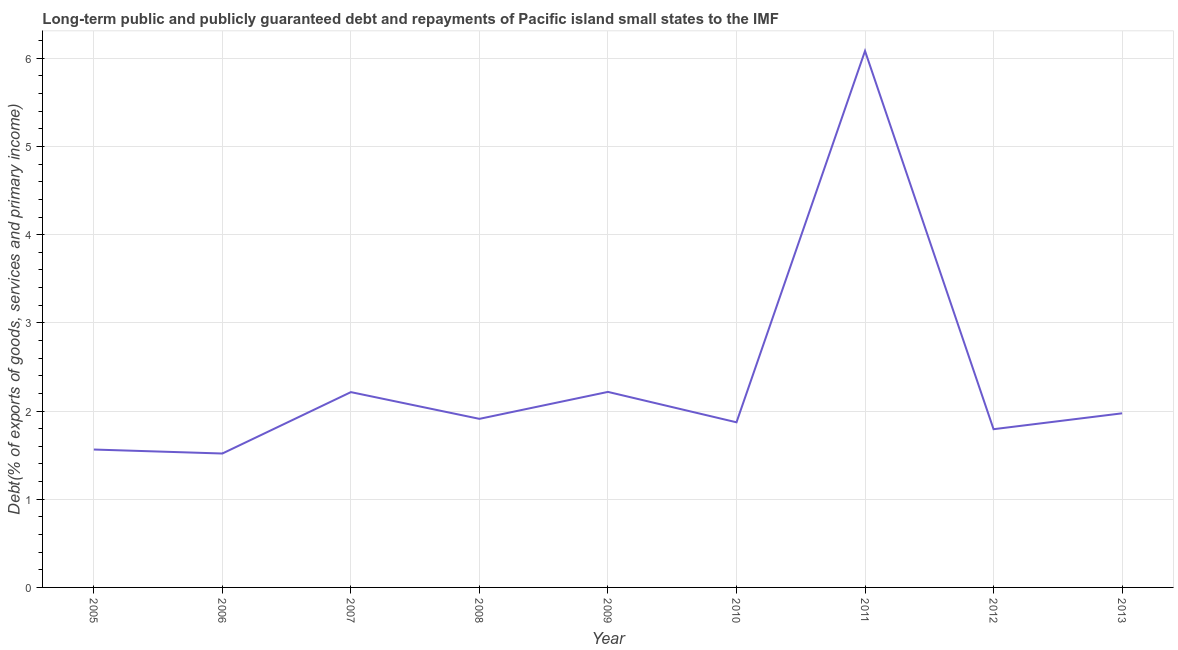What is the debt service in 2010?
Keep it short and to the point. 1.87. Across all years, what is the maximum debt service?
Provide a succinct answer. 6.08. Across all years, what is the minimum debt service?
Provide a succinct answer. 1.52. In which year was the debt service maximum?
Ensure brevity in your answer.  2011. In which year was the debt service minimum?
Provide a succinct answer. 2006. What is the sum of the debt service?
Keep it short and to the point. 21.15. What is the difference between the debt service in 2006 and 2012?
Ensure brevity in your answer.  -0.28. What is the average debt service per year?
Offer a terse response. 2.35. What is the median debt service?
Your answer should be very brief. 1.91. In how many years, is the debt service greater than 4.6 %?
Offer a very short reply. 1. What is the ratio of the debt service in 2007 to that in 2012?
Your answer should be compact. 1.23. What is the difference between the highest and the second highest debt service?
Offer a terse response. 3.87. Is the sum of the debt service in 2010 and 2013 greater than the maximum debt service across all years?
Offer a very short reply. No. What is the difference between the highest and the lowest debt service?
Provide a short and direct response. 4.56. In how many years, is the debt service greater than the average debt service taken over all years?
Ensure brevity in your answer.  1. What is the difference between two consecutive major ticks on the Y-axis?
Give a very brief answer. 1. Are the values on the major ticks of Y-axis written in scientific E-notation?
Provide a short and direct response. No. What is the title of the graph?
Provide a short and direct response. Long-term public and publicly guaranteed debt and repayments of Pacific island small states to the IMF. What is the label or title of the X-axis?
Give a very brief answer. Year. What is the label or title of the Y-axis?
Your answer should be very brief. Debt(% of exports of goods, services and primary income). What is the Debt(% of exports of goods, services and primary income) of 2005?
Your answer should be very brief. 1.56. What is the Debt(% of exports of goods, services and primary income) of 2006?
Your answer should be very brief. 1.52. What is the Debt(% of exports of goods, services and primary income) of 2007?
Ensure brevity in your answer.  2.21. What is the Debt(% of exports of goods, services and primary income) of 2008?
Ensure brevity in your answer.  1.91. What is the Debt(% of exports of goods, services and primary income) of 2009?
Give a very brief answer. 2.22. What is the Debt(% of exports of goods, services and primary income) in 2010?
Provide a short and direct response. 1.87. What is the Debt(% of exports of goods, services and primary income) of 2011?
Give a very brief answer. 6.08. What is the Debt(% of exports of goods, services and primary income) in 2012?
Ensure brevity in your answer.  1.79. What is the Debt(% of exports of goods, services and primary income) in 2013?
Offer a terse response. 1.97. What is the difference between the Debt(% of exports of goods, services and primary income) in 2005 and 2006?
Offer a very short reply. 0.05. What is the difference between the Debt(% of exports of goods, services and primary income) in 2005 and 2007?
Offer a very short reply. -0.65. What is the difference between the Debt(% of exports of goods, services and primary income) in 2005 and 2008?
Provide a succinct answer. -0.35. What is the difference between the Debt(% of exports of goods, services and primary income) in 2005 and 2009?
Your answer should be very brief. -0.65. What is the difference between the Debt(% of exports of goods, services and primary income) in 2005 and 2010?
Make the answer very short. -0.31. What is the difference between the Debt(% of exports of goods, services and primary income) in 2005 and 2011?
Your response must be concise. -4.52. What is the difference between the Debt(% of exports of goods, services and primary income) in 2005 and 2012?
Keep it short and to the point. -0.23. What is the difference between the Debt(% of exports of goods, services and primary income) in 2005 and 2013?
Give a very brief answer. -0.41. What is the difference between the Debt(% of exports of goods, services and primary income) in 2006 and 2007?
Make the answer very short. -0.7. What is the difference between the Debt(% of exports of goods, services and primary income) in 2006 and 2008?
Offer a very short reply. -0.39. What is the difference between the Debt(% of exports of goods, services and primary income) in 2006 and 2009?
Ensure brevity in your answer.  -0.7. What is the difference between the Debt(% of exports of goods, services and primary income) in 2006 and 2010?
Provide a short and direct response. -0.35. What is the difference between the Debt(% of exports of goods, services and primary income) in 2006 and 2011?
Keep it short and to the point. -4.57. What is the difference between the Debt(% of exports of goods, services and primary income) in 2006 and 2012?
Provide a short and direct response. -0.28. What is the difference between the Debt(% of exports of goods, services and primary income) in 2006 and 2013?
Ensure brevity in your answer.  -0.46. What is the difference between the Debt(% of exports of goods, services and primary income) in 2007 and 2008?
Your answer should be very brief. 0.3. What is the difference between the Debt(% of exports of goods, services and primary income) in 2007 and 2009?
Offer a very short reply. -0. What is the difference between the Debt(% of exports of goods, services and primary income) in 2007 and 2010?
Ensure brevity in your answer.  0.34. What is the difference between the Debt(% of exports of goods, services and primary income) in 2007 and 2011?
Your response must be concise. -3.87. What is the difference between the Debt(% of exports of goods, services and primary income) in 2007 and 2012?
Your answer should be compact. 0.42. What is the difference between the Debt(% of exports of goods, services and primary income) in 2007 and 2013?
Provide a short and direct response. 0.24. What is the difference between the Debt(% of exports of goods, services and primary income) in 2008 and 2009?
Give a very brief answer. -0.31. What is the difference between the Debt(% of exports of goods, services and primary income) in 2008 and 2010?
Provide a short and direct response. 0.04. What is the difference between the Debt(% of exports of goods, services and primary income) in 2008 and 2011?
Ensure brevity in your answer.  -4.17. What is the difference between the Debt(% of exports of goods, services and primary income) in 2008 and 2012?
Give a very brief answer. 0.12. What is the difference between the Debt(% of exports of goods, services and primary income) in 2008 and 2013?
Provide a short and direct response. -0.06. What is the difference between the Debt(% of exports of goods, services and primary income) in 2009 and 2010?
Make the answer very short. 0.34. What is the difference between the Debt(% of exports of goods, services and primary income) in 2009 and 2011?
Your answer should be compact. -3.87. What is the difference between the Debt(% of exports of goods, services and primary income) in 2009 and 2012?
Your response must be concise. 0.42. What is the difference between the Debt(% of exports of goods, services and primary income) in 2009 and 2013?
Offer a very short reply. 0.24. What is the difference between the Debt(% of exports of goods, services and primary income) in 2010 and 2011?
Ensure brevity in your answer.  -4.21. What is the difference between the Debt(% of exports of goods, services and primary income) in 2010 and 2012?
Keep it short and to the point. 0.08. What is the difference between the Debt(% of exports of goods, services and primary income) in 2010 and 2013?
Your response must be concise. -0.1. What is the difference between the Debt(% of exports of goods, services and primary income) in 2011 and 2012?
Ensure brevity in your answer.  4.29. What is the difference between the Debt(% of exports of goods, services and primary income) in 2011 and 2013?
Your answer should be very brief. 4.11. What is the difference between the Debt(% of exports of goods, services and primary income) in 2012 and 2013?
Keep it short and to the point. -0.18. What is the ratio of the Debt(% of exports of goods, services and primary income) in 2005 to that in 2007?
Your answer should be compact. 0.71. What is the ratio of the Debt(% of exports of goods, services and primary income) in 2005 to that in 2008?
Ensure brevity in your answer.  0.82. What is the ratio of the Debt(% of exports of goods, services and primary income) in 2005 to that in 2009?
Provide a short and direct response. 0.7. What is the ratio of the Debt(% of exports of goods, services and primary income) in 2005 to that in 2010?
Offer a terse response. 0.83. What is the ratio of the Debt(% of exports of goods, services and primary income) in 2005 to that in 2011?
Provide a short and direct response. 0.26. What is the ratio of the Debt(% of exports of goods, services and primary income) in 2005 to that in 2012?
Your response must be concise. 0.87. What is the ratio of the Debt(% of exports of goods, services and primary income) in 2005 to that in 2013?
Provide a short and direct response. 0.79. What is the ratio of the Debt(% of exports of goods, services and primary income) in 2006 to that in 2007?
Give a very brief answer. 0.69. What is the ratio of the Debt(% of exports of goods, services and primary income) in 2006 to that in 2008?
Your response must be concise. 0.79. What is the ratio of the Debt(% of exports of goods, services and primary income) in 2006 to that in 2009?
Your response must be concise. 0.69. What is the ratio of the Debt(% of exports of goods, services and primary income) in 2006 to that in 2010?
Provide a succinct answer. 0.81. What is the ratio of the Debt(% of exports of goods, services and primary income) in 2006 to that in 2012?
Give a very brief answer. 0.85. What is the ratio of the Debt(% of exports of goods, services and primary income) in 2006 to that in 2013?
Offer a terse response. 0.77. What is the ratio of the Debt(% of exports of goods, services and primary income) in 2007 to that in 2008?
Your answer should be very brief. 1.16. What is the ratio of the Debt(% of exports of goods, services and primary income) in 2007 to that in 2009?
Offer a terse response. 1. What is the ratio of the Debt(% of exports of goods, services and primary income) in 2007 to that in 2010?
Keep it short and to the point. 1.18. What is the ratio of the Debt(% of exports of goods, services and primary income) in 2007 to that in 2011?
Give a very brief answer. 0.36. What is the ratio of the Debt(% of exports of goods, services and primary income) in 2007 to that in 2012?
Your response must be concise. 1.23. What is the ratio of the Debt(% of exports of goods, services and primary income) in 2007 to that in 2013?
Keep it short and to the point. 1.12. What is the ratio of the Debt(% of exports of goods, services and primary income) in 2008 to that in 2009?
Make the answer very short. 0.86. What is the ratio of the Debt(% of exports of goods, services and primary income) in 2008 to that in 2011?
Your answer should be compact. 0.31. What is the ratio of the Debt(% of exports of goods, services and primary income) in 2008 to that in 2012?
Make the answer very short. 1.06. What is the ratio of the Debt(% of exports of goods, services and primary income) in 2009 to that in 2010?
Ensure brevity in your answer.  1.18. What is the ratio of the Debt(% of exports of goods, services and primary income) in 2009 to that in 2011?
Offer a terse response. 0.36. What is the ratio of the Debt(% of exports of goods, services and primary income) in 2009 to that in 2012?
Provide a short and direct response. 1.24. What is the ratio of the Debt(% of exports of goods, services and primary income) in 2009 to that in 2013?
Offer a terse response. 1.12. What is the ratio of the Debt(% of exports of goods, services and primary income) in 2010 to that in 2011?
Provide a short and direct response. 0.31. What is the ratio of the Debt(% of exports of goods, services and primary income) in 2010 to that in 2012?
Give a very brief answer. 1.04. What is the ratio of the Debt(% of exports of goods, services and primary income) in 2010 to that in 2013?
Ensure brevity in your answer.  0.95. What is the ratio of the Debt(% of exports of goods, services and primary income) in 2011 to that in 2012?
Make the answer very short. 3.39. What is the ratio of the Debt(% of exports of goods, services and primary income) in 2011 to that in 2013?
Your answer should be compact. 3.08. What is the ratio of the Debt(% of exports of goods, services and primary income) in 2012 to that in 2013?
Your answer should be compact. 0.91. 